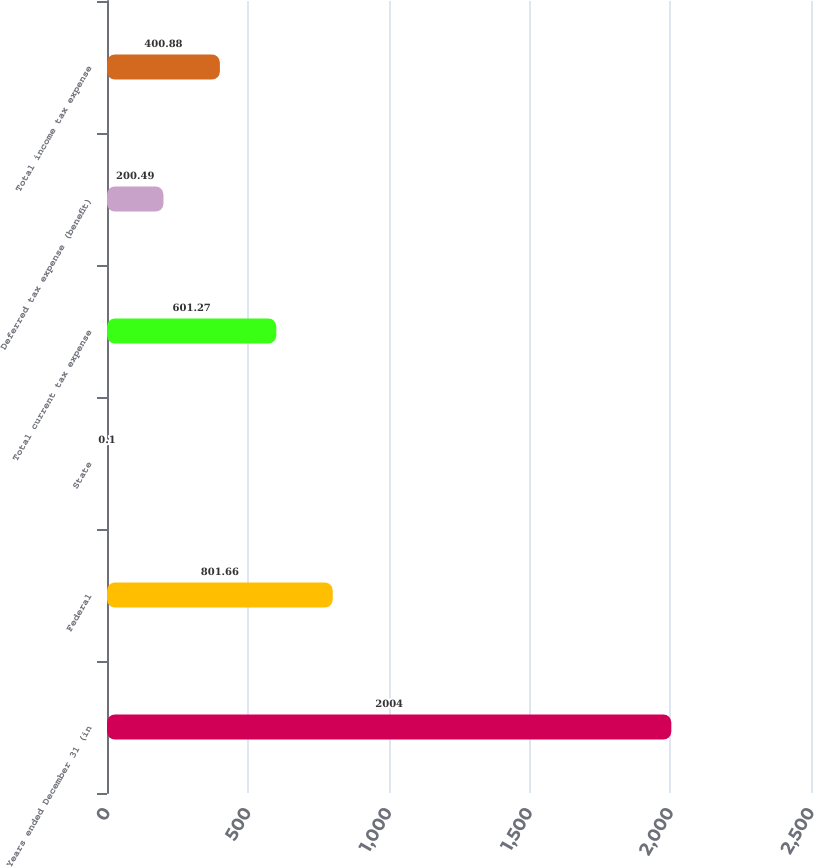Convert chart to OTSL. <chart><loc_0><loc_0><loc_500><loc_500><bar_chart><fcel>Years ended December 31 (in<fcel>Federal<fcel>State<fcel>Total current tax expense<fcel>Deferred tax expense (benefit)<fcel>Total income tax expense<nl><fcel>2004<fcel>801.66<fcel>0.1<fcel>601.27<fcel>200.49<fcel>400.88<nl></chart> 